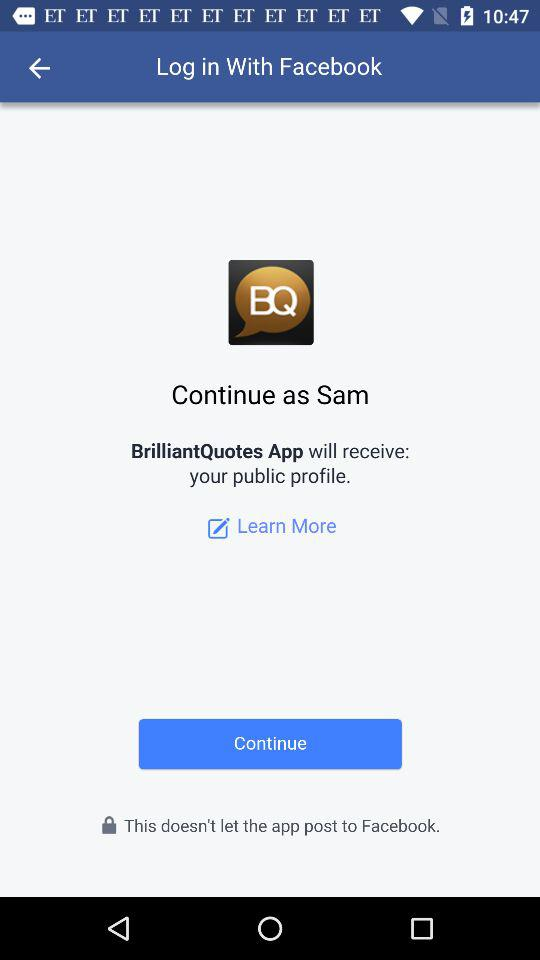What is the full name of the app? The full name of the app is "BrilliantQuotes". 